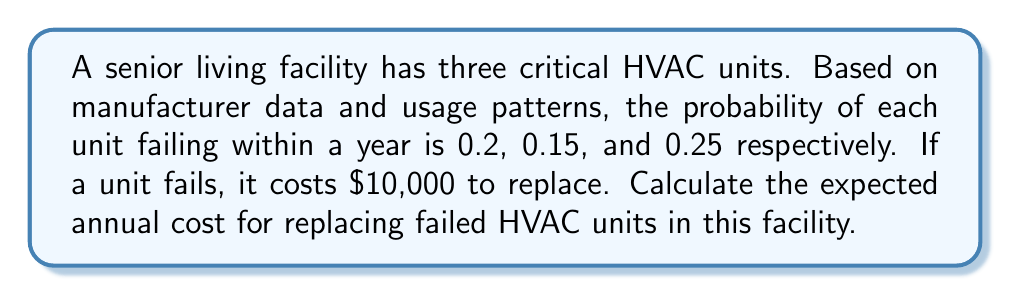Provide a solution to this math problem. To solve this problem, we need to calculate the expected value of the replacement costs. Let's approach this step-by-step:

1) For each HVAC unit, we can calculate the expected cost of replacement:

   Unit 1: $E_1 = 0.2 \times \$10,000 = \$2,000$
   Unit 2: $E_2 = 0.15 \times \$10,000 = \$1,500$
   Unit 3: $E_3 = 0.25 \times \$10,000 = \$2,500$

2) The total expected cost is the sum of these individual expected costs:

   $E_{total} = E_1 + E_2 + E_3$

3) Substituting the values:

   $E_{total} = \$2,000 + \$1,500 + \$2,500$

4) Calculating the final result:

   $E_{total} = \$6,000$

Therefore, the expected annual cost for replacing failed HVAC units in this facility is $6,000.
Answer: $6,000 